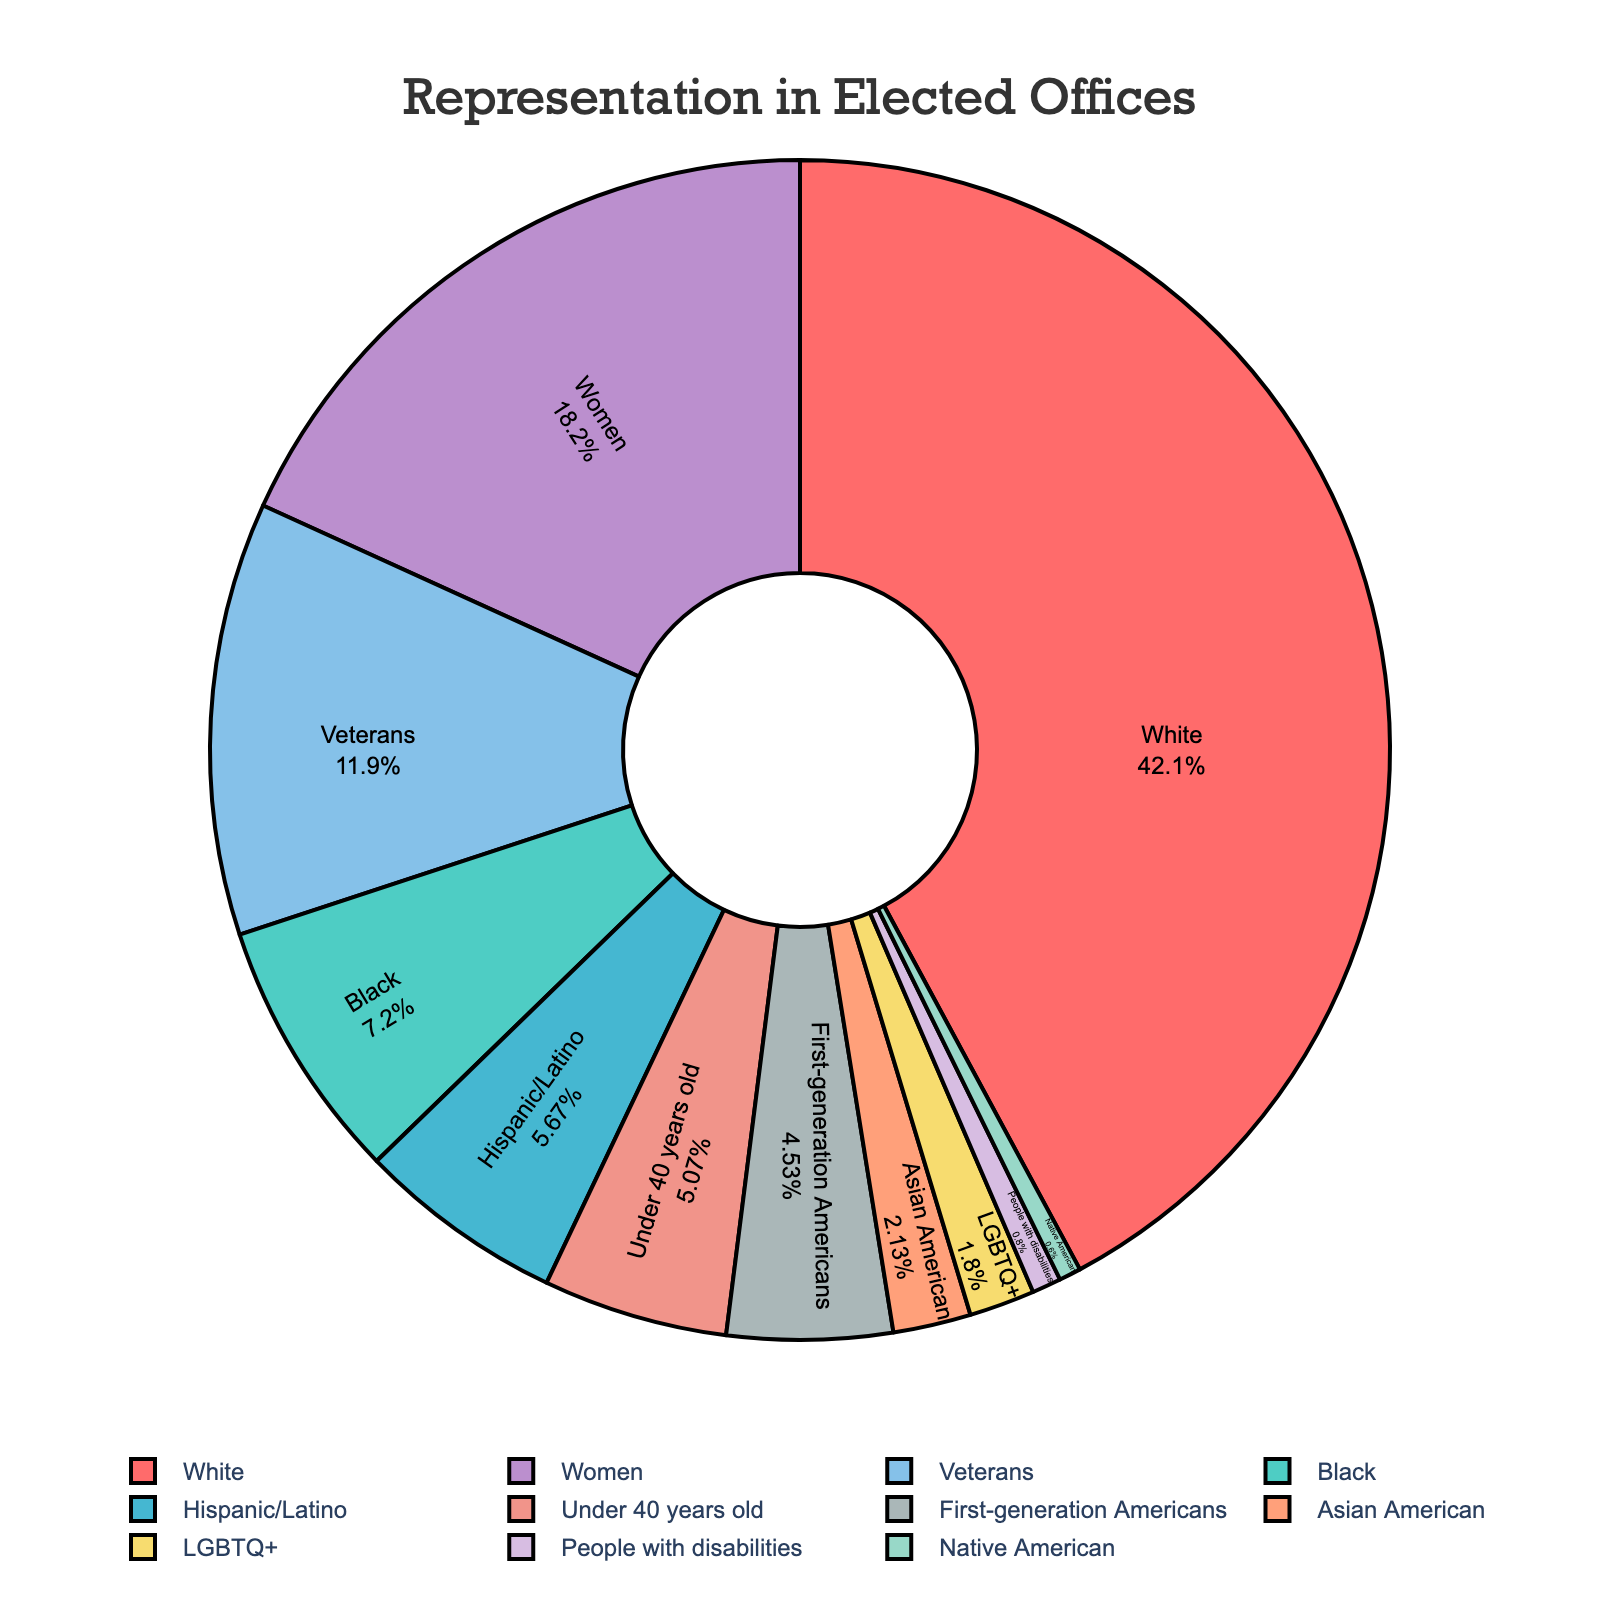Which demographic group has the highest representation in elected offices? The pie chart shows different demographic groups, and the "White" category has the largest segment among all, indicating the highest representation.
Answer: White Which demographic group has the smallest representation in elected offices? The smallest segment in the pie chart represents the "Native American" group, indicating the least representation among all demographics.
Answer: Native American How does the representation of women compare to that of men (assuming men are the complementary group)? The pie chart shows that women have a representation of 27.3%. Men, being the complementary group, would have a representation of 100% - 27.3% = 72.7%.
Answer: Men are more represented What is the total percentage of representation for minority groups (Black, Hispanic/Latino, Asian American, Native American, LGBTQ+, People with disabilities, First-generation Americans)? Sum the percentages: 10.8 + 8.5 + 3.2 + 0.9 + 2.7 + 1.2 + 6.8 = 34.1%.
Answer: 34.1% Which group has a higher representation: Veterans or First-generation Americans? The pie chart shows that veterans have a percentage of 17.8% while First-generation Americans have 6.8%, so veterans have higher representation.
Answer: Veterans Compare the representation of LGBTQ+ individuals to that of people with disabilities. The pie chart shows that LGBTQ+ individuals have a representation of 2.7% while people with disabilities have 1.2%, so LGBTQ+ individuals have higher representation.
Answer: LGBTQ+ individuals Which group has a higher representation: Asian Americans or Under 40 years old? The pie chart indicates that those under 40 years old have a representation of 7.6%. In comparison, Asian Americans have 3.2%. Thus, Under 40 years old has higher representation.
Answer: Under 40 years old Which two groups combined have a percentage close to the representation of White individuals? Summing the two highest percentages other than "White", 17.8% (Veterans) and 10.8% (Black), gives us 28.6%. Adding Hispanic/Latino's 8.5% gives 37.1%. Since 37.1% is quite different from 63.2%, the combined percentage of these two or three groups is not close. Thus, none of these combinations reach close to 63.2%.
Answer: None can match closely What is the combined representation percentage of Asian American and First-generation Americans? Sum the percentages: 3.2% (Asian American) + 6.8% (First-generation Americans) = 10%.
Answer: 10% How does the representation of people under 40 years old compare to LGBTQ+ individuals? The pie chart indicates 7.6% for Under 40 years old compared to 2.7% for LGBTQ+ individuals. The percentage for Under 40 years old is higher.
Answer: Under 40 years old 